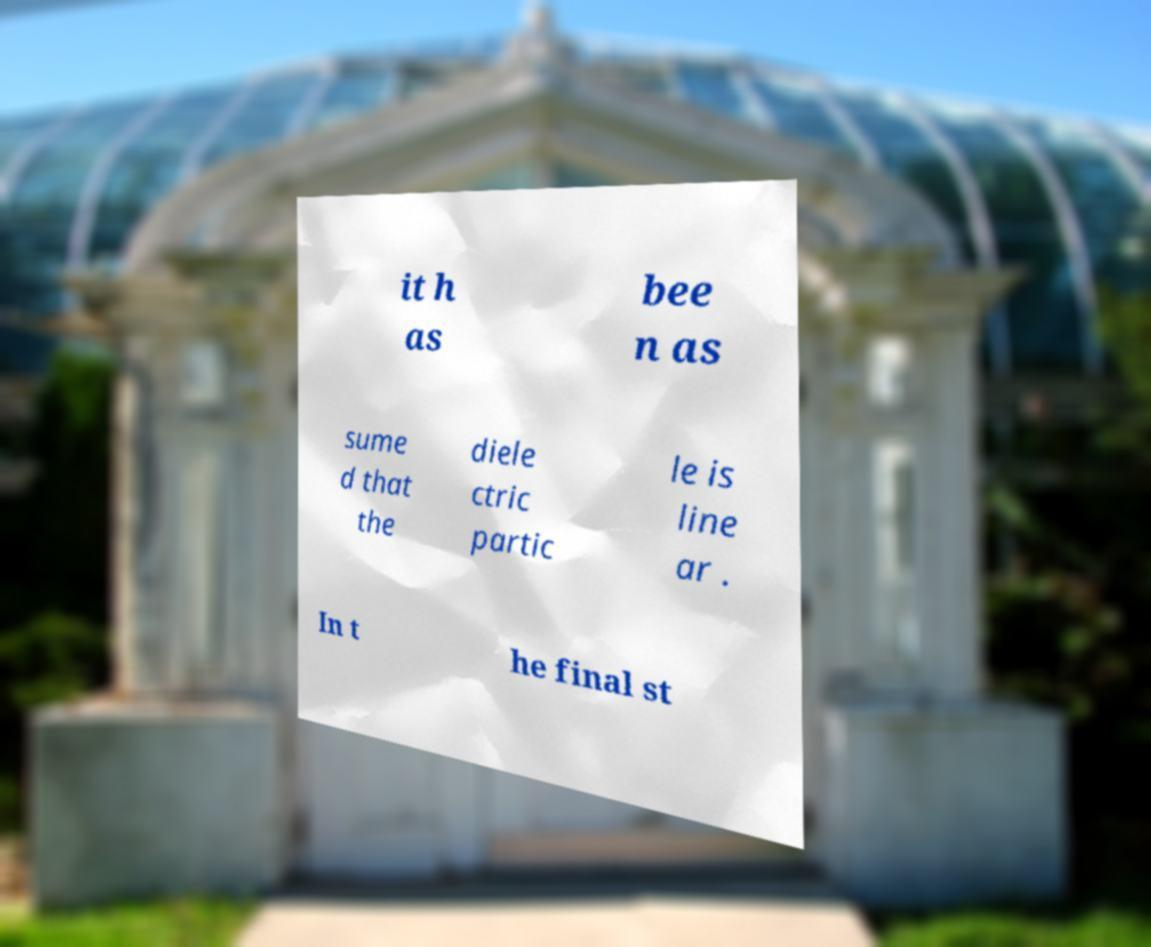Can you accurately transcribe the text from the provided image for me? it h as bee n as sume d that the diele ctric partic le is line ar . In t he final st 